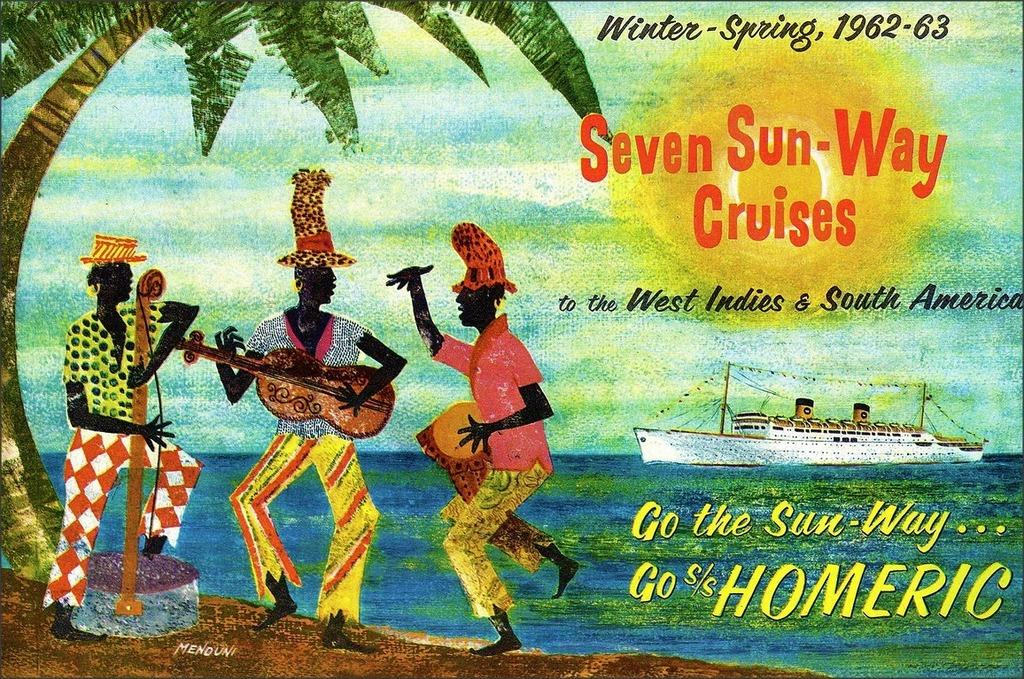Provide a one-sentence caption for the provided image. A very old advertising poster for seven sun-way cruises depicts an idyllic carribbean setting. 